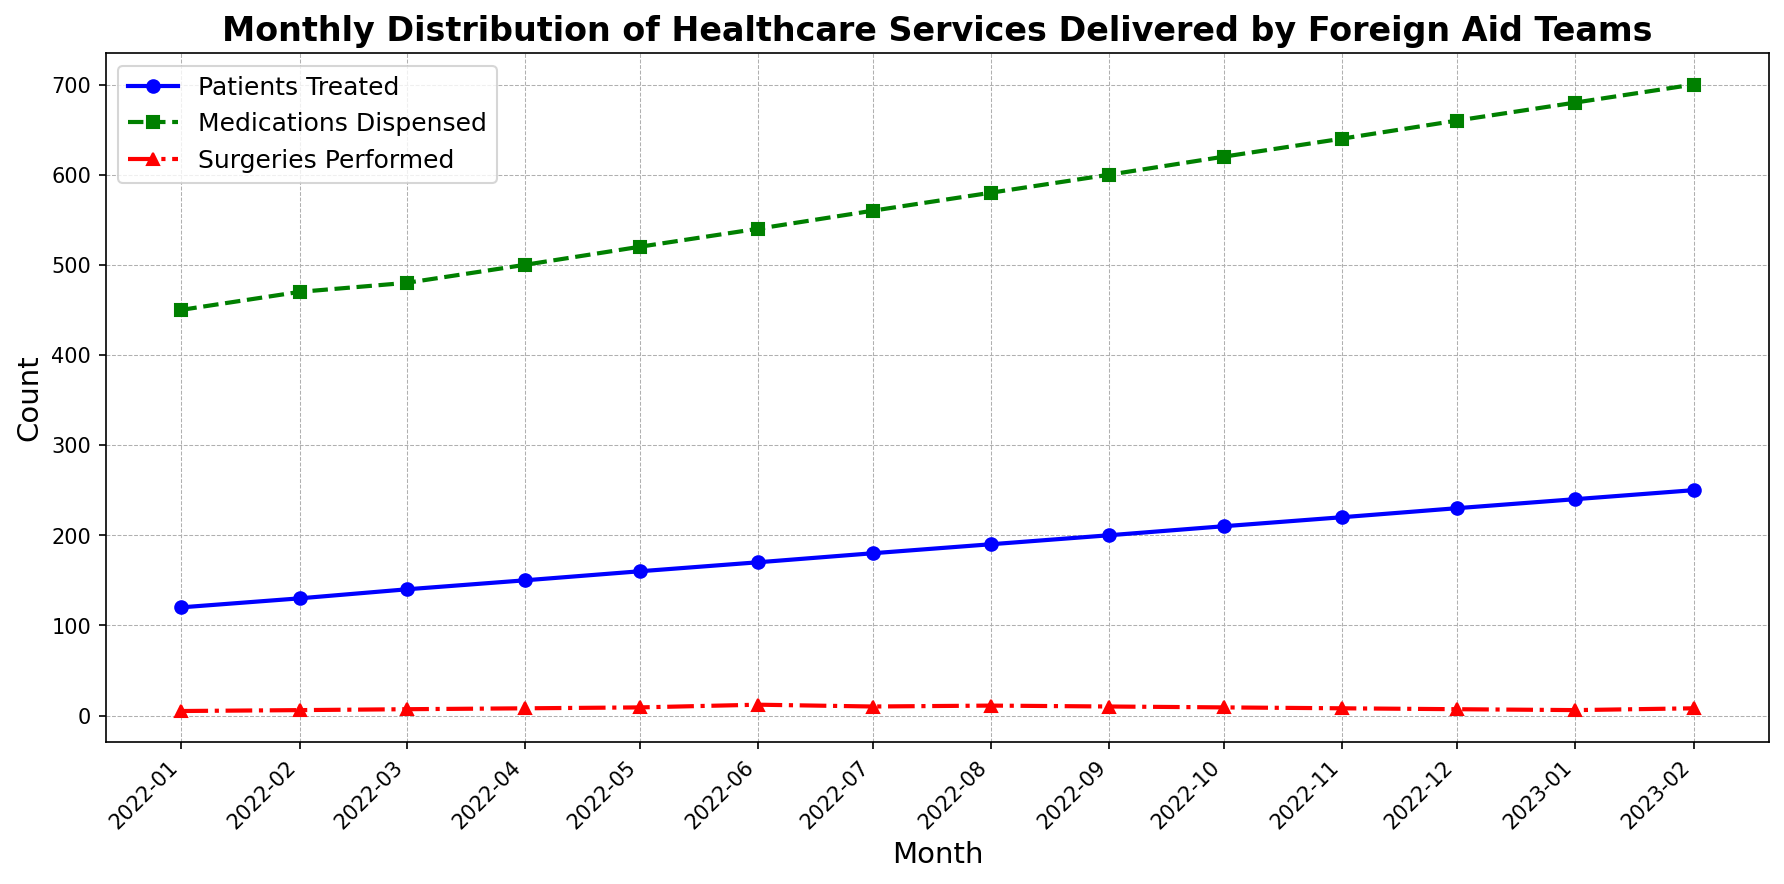Which month had the highest number of patients treated? The line representing 'Patients Treated' is highest in February 2023, reaching a value of 250.
Answer: February 2023 In which month were the most medications dispensed? The green line, representing 'Medications Dispensed,' peaks in February 2023, with a value of 700.
Answer: February 2023 How many more patients were treated in January 2023 than in December 2022? Compare the 'Patients Treated' values for January 2023 (240) and December 2022 (230). The difference is 240 - 230.
Answer: 10 Which service showed the most consistent increase over the months? All lines generally show an upward trend, but 'Patients Treated' has a smooth gradual increase each month, with no drops.
Answer: Patients Treated What is the average number of surgeries performed over the entire period? Sum all the 'Surgeries Performed' values (5 + 6 + 7 + 8 + 9 + 12 + 10 + 11 + 10 + 9 + 8 + 7 + 6 + 8) = 116, then divide by 14 months.
Answer: 8.29 In which months did the number of surgeries performed decrease compared to the previous month? Look at the 'Surgeries Performed' line and identify any drops: December 2022 (7) vs. November 2022 (8), January 2023 (6) vs. December 2022 (7).
Answer: December 2022 and January 2023 By how much did the number of medications dispensed increase from January 2022 to February 2022? Compare values: February 2022 (470) - January 2022 (450) = 20.
Answer: 20 Which month shows the steepest increase in the number of patients treated? The sharpest upward slope for 'Patients Treated' occurs between December 2022 (230) and January 2023 (240), indicating a 10 unit increase.
Answer: January 2023 What is the visual difference in the trend lines representing 'Medications Dispensed' and 'Surgeries Performed'? The 'Medications Dispensed' line (green) consistently rises with minor fluctuations, whereas the 'Surgeries Performed' line (red) has more variations and occasional drops.
Answer: Consistent rise vs. fluctuating trend Which month had the same number of surgeries performed as May 2022? May 2022 had 9 surgeries. Look for the same height in the red line, which occurs in October 2022.
Answer: October 2022 